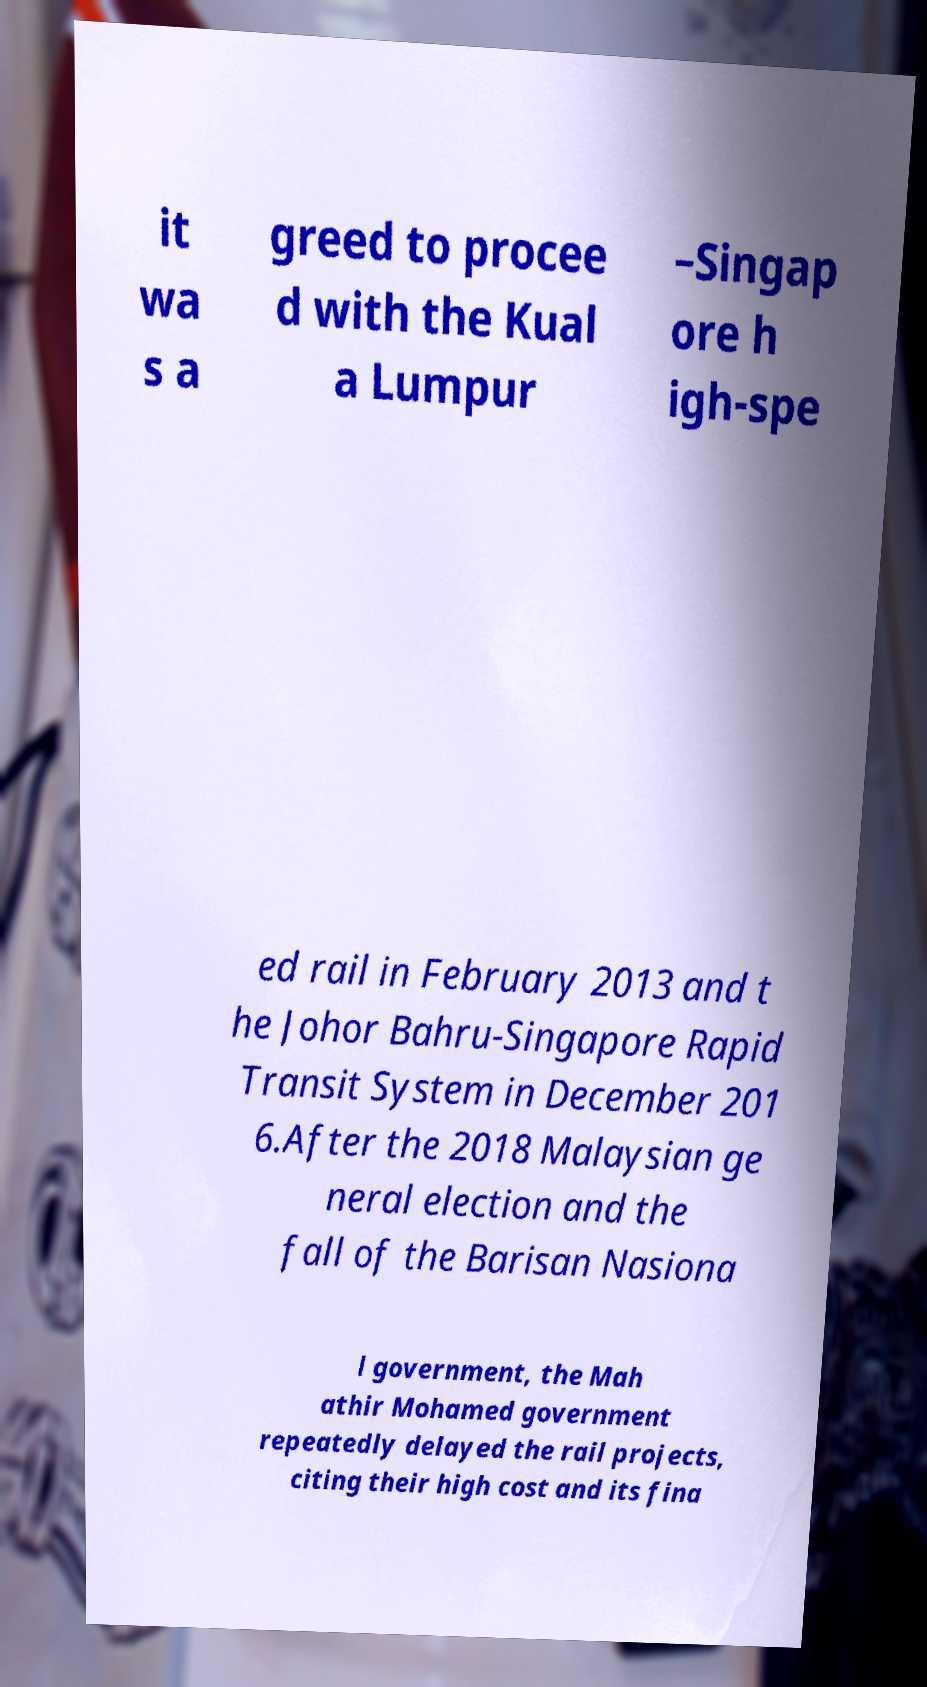Please identify and transcribe the text found in this image. it wa s a greed to procee d with the Kual a Lumpur –Singap ore h igh-spe ed rail in February 2013 and t he Johor Bahru-Singapore Rapid Transit System in December 201 6.After the 2018 Malaysian ge neral election and the fall of the Barisan Nasiona l government, the Mah athir Mohamed government repeatedly delayed the rail projects, citing their high cost and its fina 